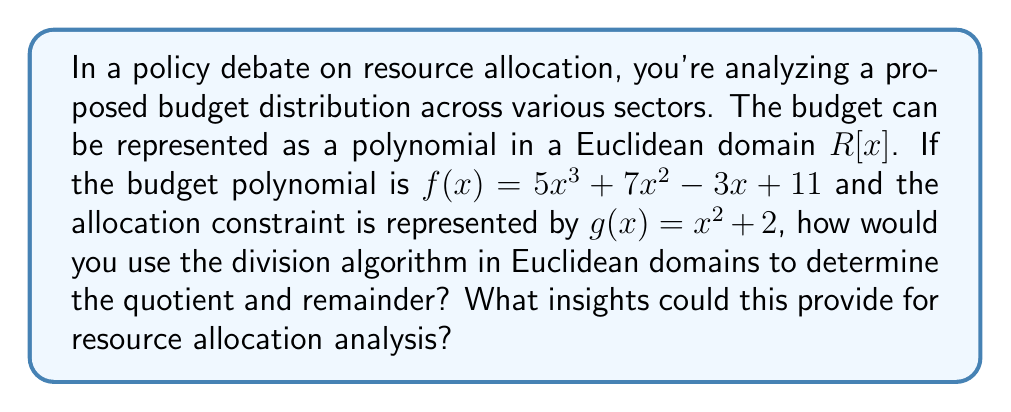Provide a solution to this math problem. To solve this problem, we'll use the division algorithm in the Euclidean domain $R[x]$. The division algorithm states that for polynomials $f(x)$ and $g(x)$ in a Euclidean domain, there exist unique polynomials $q(x)$ (quotient) and $r(x)$ (remainder) such that:

$$f(x) = g(x)q(x) + r(x)$$

where the degree of $r(x)$ is less than the degree of $g(x)$ or $r(x) = 0$.

Let's perform the polynomial long division:

$$\begin{array}{r}
5x + 7 \\
x^2 + 2 \enclose{longdiv}{5x^3 + 7x^2 - 3x + 11} \\
\underline{5x^3 + 10x} \\
7x^2 - 13x + 11 \\
\underline{7x^2 + 14} \\
-13x - 3 \\
\end{array}$$

Therefore, 
$$q(x) = 5x + 7$$
$$r(x) = -13x - 3$$

In the context of policy analysis and resource allocation:

1. The quotient $q(x) = 5x + 7$ represents the main allocation strategy that fits within the constraint $g(x)$.
2. The remainder $r(x) = -13x - 3$ represents resources that don't fit neatly into the main allocation strategy and may require special consideration.
3. The degree of $r(x)$ (which is 1) being less than the degree of $g(x)$ (which is 2) ensures that the remainder is as small as possible given the constraint.

This mathematical approach can provide insights for resource allocation by:

a) Identifying the primary allocation strategy (represented by the quotient).
b) Highlighting residual resources or needs (represented by the remainder) that may require alternative allocation methods.
c) Ensuring efficient use of resources by minimizing the remainder within the given constraints.
d) Providing a structured way to analyze and compare different budget proposals using the same constraint function.
Answer: Quotient: $q(x) = 5x + 7$
Remainder: $r(x) = -13x - 3$ 